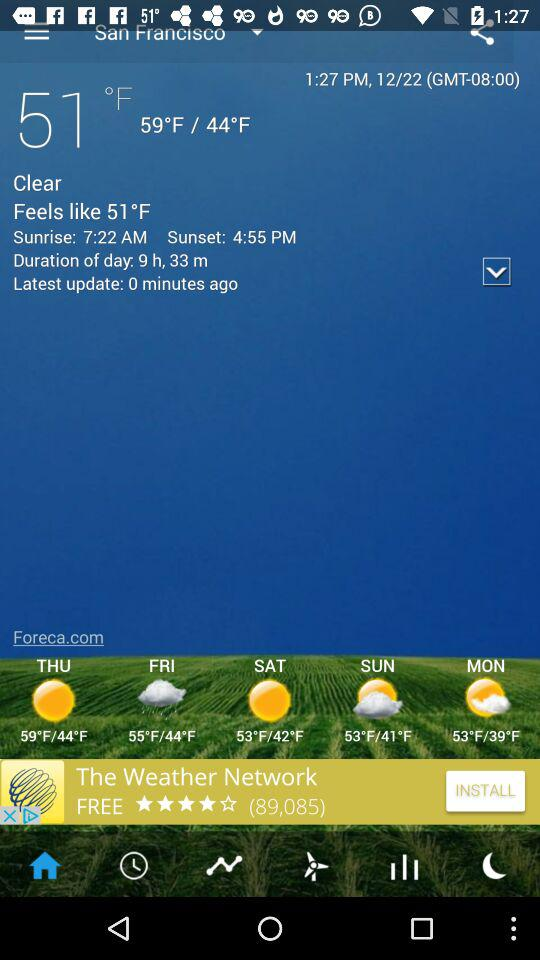How many hours of daylight are there today?
Answer the question using a single word or phrase. 9 h, 33 m 